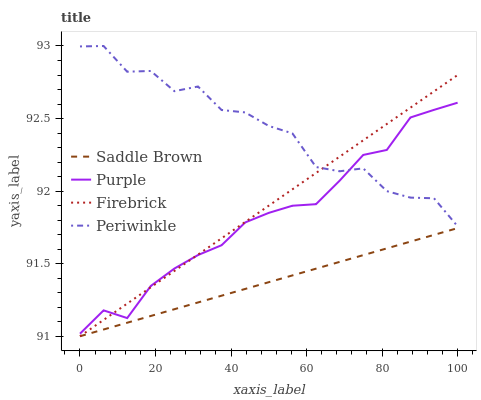Does Saddle Brown have the minimum area under the curve?
Answer yes or no. Yes. Does Periwinkle have the maximum area under the curve?
Answer yes or no. Yes. Does Firebrick have the minimum area under the curve?
Answer yes or no. No. Does Firebrick have the maximum area under the curve?
Answer yes or no. No. Is Saddle Brown the smoothest?
Answer yes or no. Yes. Is Periwinkle the roughest?
Answer yes or no. Yes. Is Firebrick the smoothest?
Answer yes or no. No. Is Firebrick the roughest?
Answer yes or no. No. Does Firebrick have the lowest value?
Answer yes or no. Yes. Does Periwinkle have the lowest value?
Answer yes or no. No. Does Periwinkle have the highest value?
Answer yes or no. Yes. Does Firebrick have the highest value?
Answer yes or no. No. Is Saddle Brown less than Purple?
Answer yes or no. Yes. Is Periwinkle greater than Saddle Brown?
Answer yes or no. Yes. Does Firebrick intersect Periwinkle?
Answer yes or no. Yes. Is Firebrick less than Periwinkle?
Answer yes or no. No. Is Firebrick greater than Periwinkle?
Answer yes or no. No. Does Saddle Brown intersect Purple?
Answer yes or no. No. 